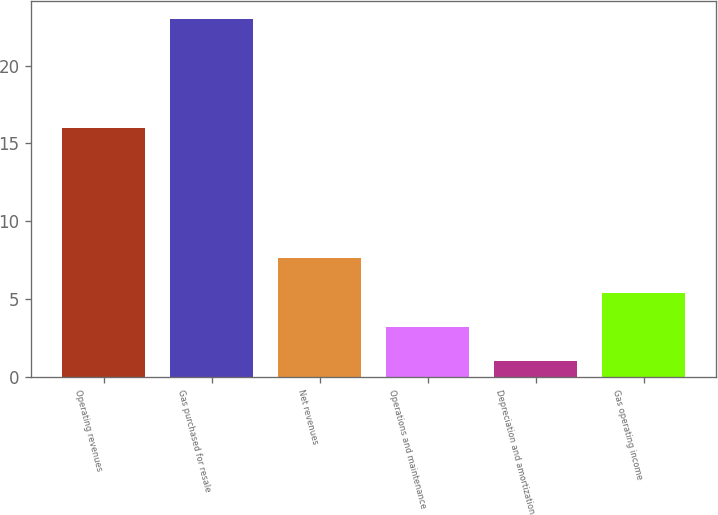Convert chart. <chart><loc_0><loc_0><loc_500><loc_500><bar_chart><fcel>Operating revenues<fcel>Gas purchased for resale<fcel>Net revenues<fcel>Operations and maintenance<fcel>Depreciation and amortization<fcel>Gas operating income<nl><fcel>16<fcel>23<fcel>7.6<fcel>3.2<fcel>1<fcel>5.4<nl></chart> 